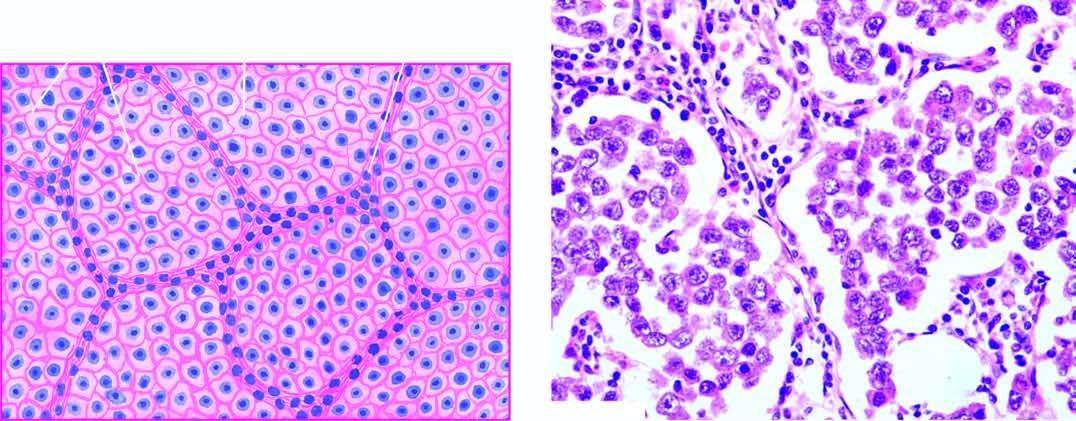what shows lobules of monomorphic seminoma cells separated by delicate fibrous stroma containing lymphocytic infiltration?
Answer the question using a single word or phrase. Microscopy of the tumour 